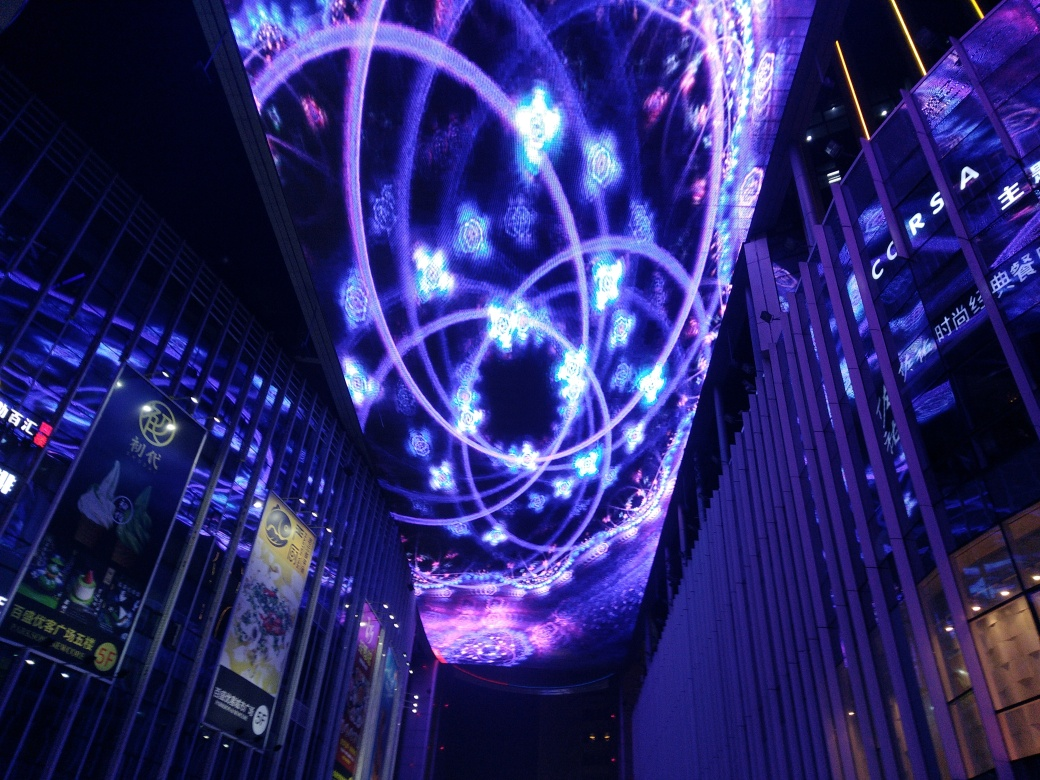How might the mood or atmosphere be described in this setting? The overall mood in this setting appears to be lively and awe-inspiring. The combination of bright colors and futuristic patterns gives off a sense of wonder, reflecting a high-energy, electrifying atmosphere typically found in modern entertainment districts or during special nighttime events. 